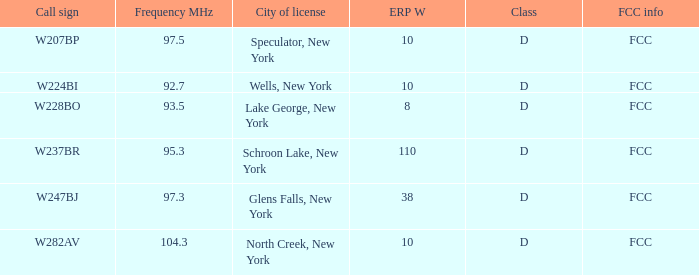3 mhz and the call sign of w237br. FCC. 